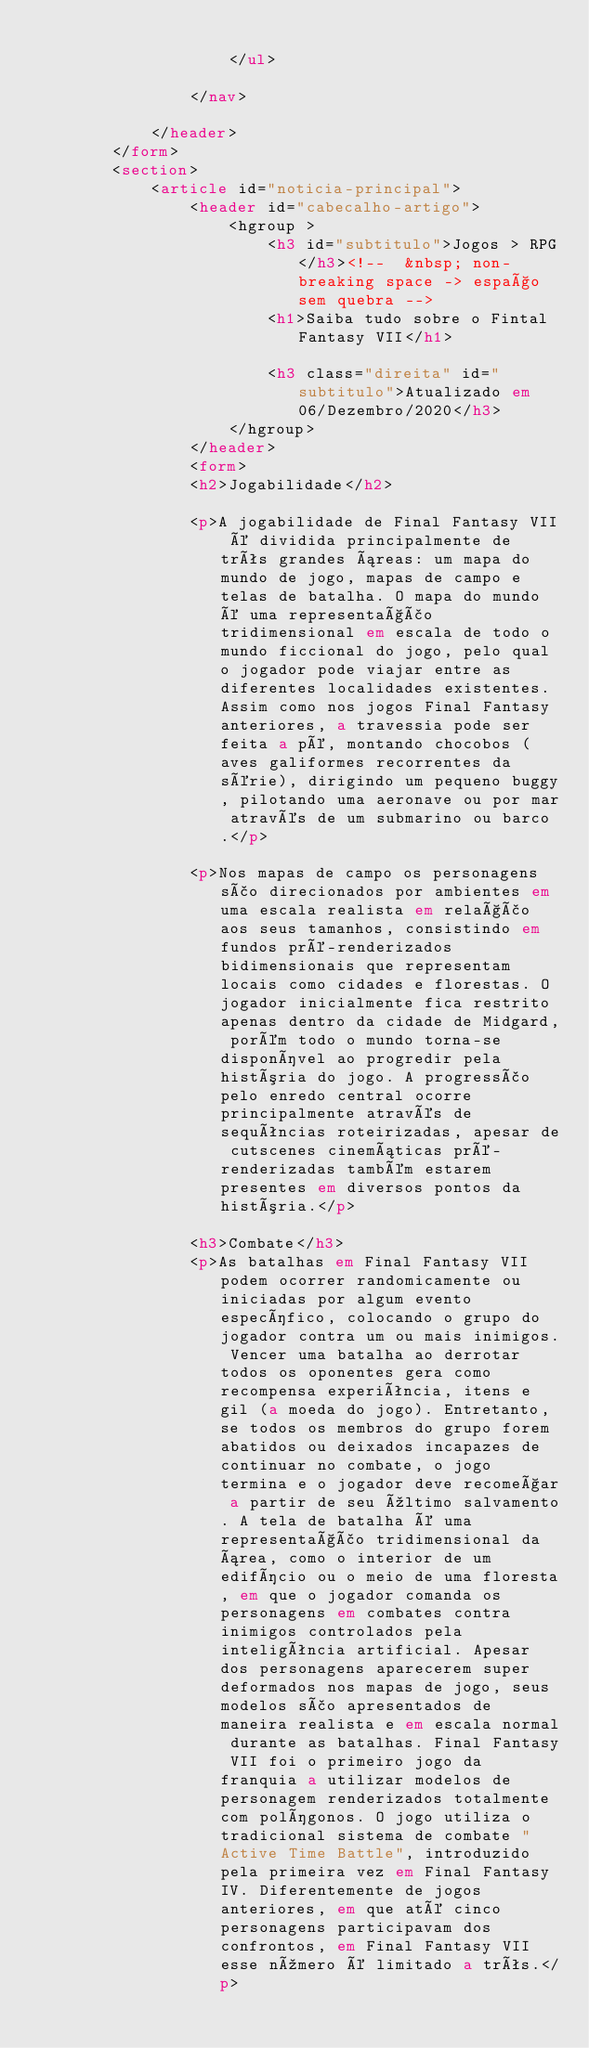Convert code to text. <code><loc_0><loc_0><loc_500><loc_500><_HTML_>
                    </ul>

                </nav>

            </header>
        </form>
        <section>
            <article id="noticia-principal">
                <header id="cabecalho-artigo">
                    <hgroup >
                        <h3 id="subtitulo">Jogos > RPG</h3><!--  &nbsp; non-breaking space -> espaço sem quebra -->
                        <h1>Saiba tudo sobre o Fintal Fantasy VII</h1>

                        <h3 class="direita" id="subtitulo">Atualizado em 06/Dezembro/2020</h3>
                    </hgroup>
                </header>
                <form>
                <h2>Jogabilidade</h2>

                <p>A jogabilidade de Final Fantasy VII é dividida principalmente de três grandes áreas: um mapa do mundo de jogo, mapas de campo e telas de batalha. O mapa do mundo é uma representação tridimensional em escala de todo o mundo ficcional do jogo, pelo qual o jogador pode viajar entre as diferentes localidades existentes. Assim como nos jogos Final Fantasy anteriores, a travessia pode ser feita a pé, montando chocobos (aves galiformes recorrentes da série), dirigindo um pequeno buggy, pilotando uma aeronave ou por mar através de um submarino ou barco.</p>

                <p>Nos mapas de campo os personagens são direcionados por ambientes em uma escala realista em relação aos seus tamanhos, consistindo em fundos pré-renderizados bidimensionais que representam locais como cidades e florestas. O jogador inicialmente fica restrito apenas dentro da cidade de Midgard, porém todo o mundo torna-se disponível ao progredir pela história do jogo. A progressão pelo enredo central ocorre principalmente através de sequências roteirizadas, apesar de cutscenes cinemáticas pré-renderizadas também estarem presentes em diversos pontos da história.</p>

                <h3>Combate</h3>
                <p>As batalhas em Final Fantasy VII podem ocorrer randomicamente ou iniciadas por algum evento específico, colocando o grupo do jogador contra um ou mais inimigos. Vencer uma batalha ao derrotar todos os oponentes gera como recompensa experiência, itens e gil (a moeda do jogo). Entretanto, se todos os membros do grupo forem abatidos ou deixados incapazes de continuar no combate, o jogo termina e o jogador deve recomeçar a partir de seu último salvamento. A tela de batalha é uma representação tridimensional da área, como o interior de um edifício ou o meio de uma floresta, em que o jogador comanda os personagens em combates contra inimigos controlados pela inteligência artificial. Apesar dos personagens aparecerem super deformados nos mapas de jogo, seus modelos são apresentados de maneira realista e em escala normal durante as batalhas. Final Fantasy VII foi o primeiro jogo da franquia a utilizar modelos de personagem renderizados totalmente com polígonos. O jogo utiliza o tradicional sistema de combate "Active Time Battle", introduzido pela primeira vez em Final Fantasy IV. Diferentemente de jogos anteriores, em que até cinco personagens participavam dos confrontos, em Final Fantasy VII esse número é limitado a três.</p></code> 